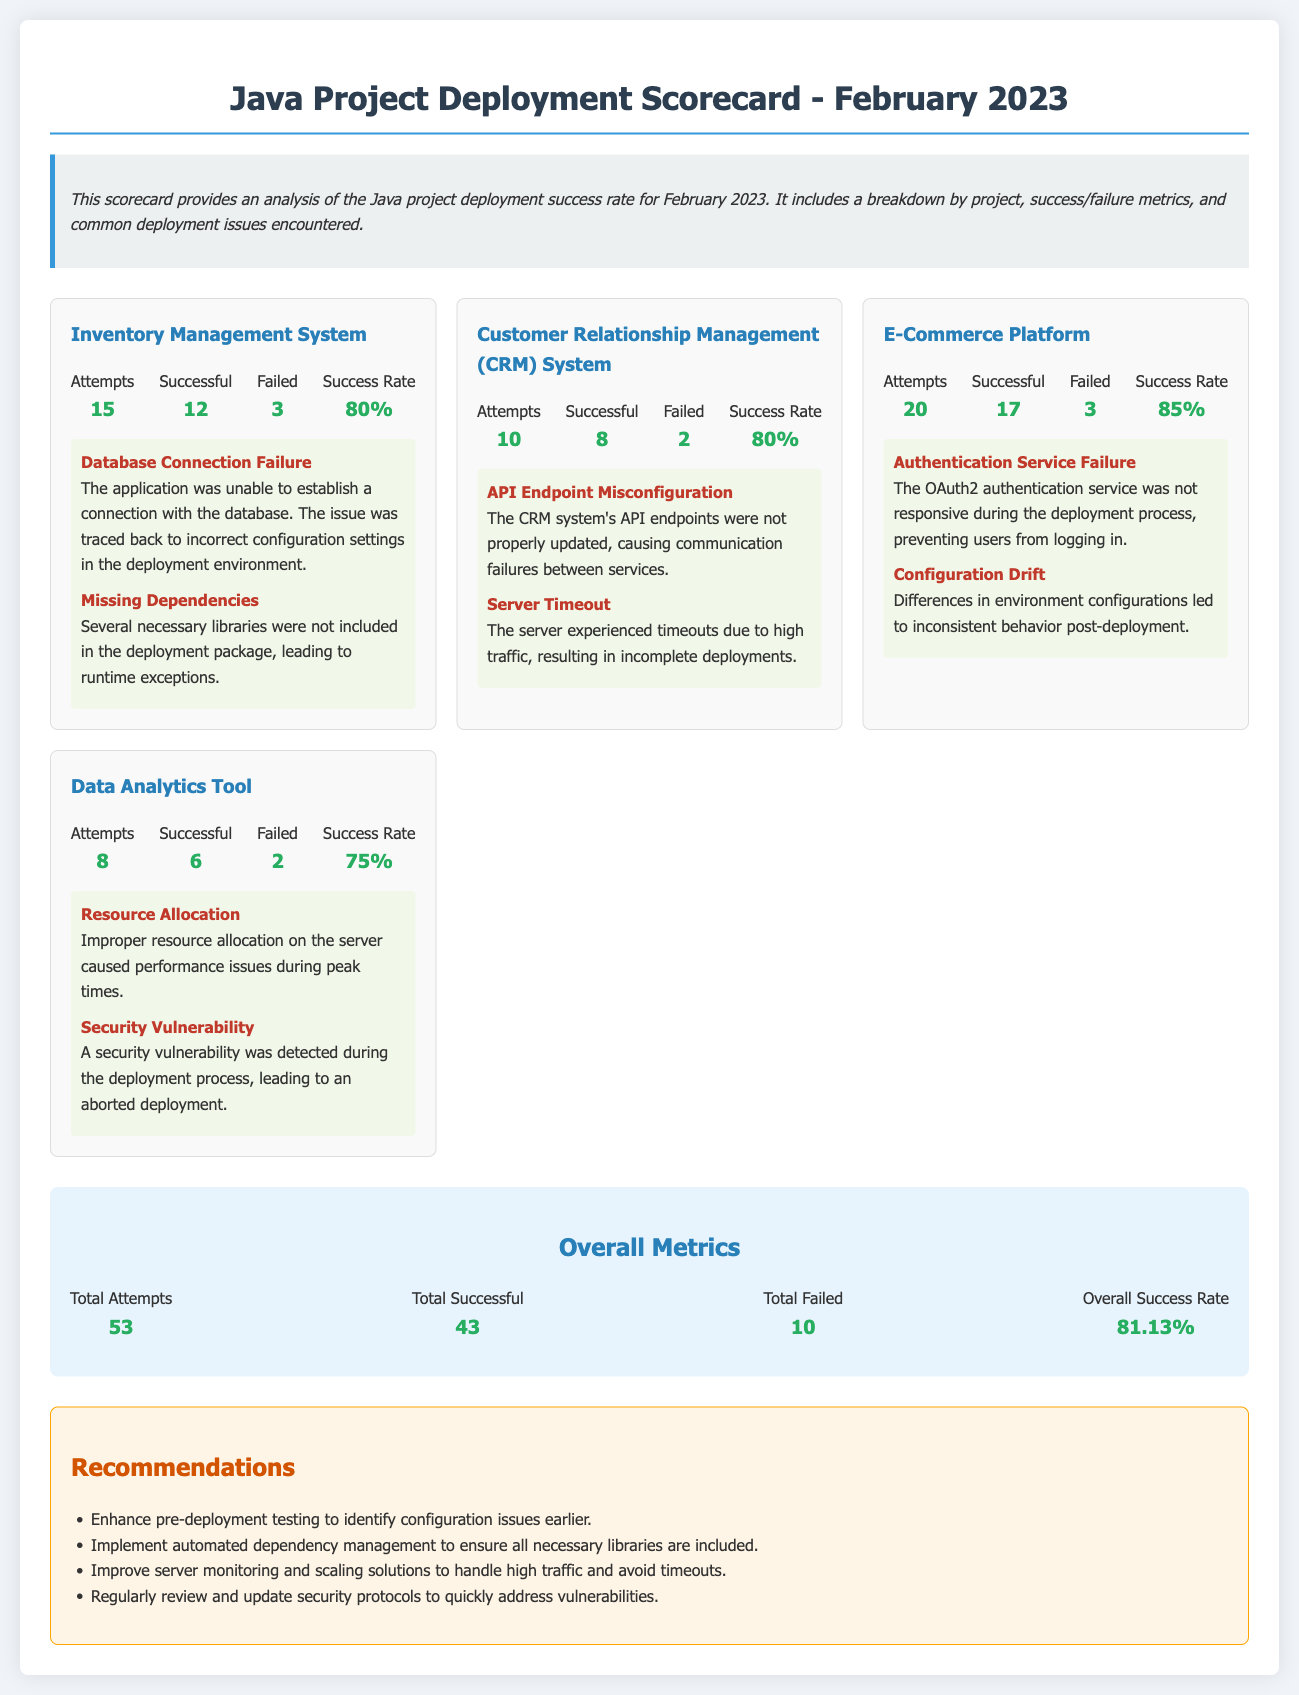What is the success rate of the Inventory Management System? The success rate for the Inventory Management System is provided under its metrics section.
Answer: 80% How many total attempts were made across all projects? The total attempts are shown in the overall metrics section by summing the attempts from each project.
Answer: 53 Which project had the highest success rate? By comparing the success rates of each project listed, the one with the highest rate can be determined.
Answer: E-Commerce Platform What was the total number of failures recorded in February 2023? The total failures can be identified by adding the failed metrics of each project in the overall metrics section.
Answer: 10 What issue was identified in the Customer Relationship Management System? The document lists specific deployment issues for each project, mentioning problems for the CRM system.
Answer: API Endpoint Misconfiguration How many successful deployments were recorded for the E-Commerce Platform? This number can be found in the metrics section specific to the E-Commerce Platform.
Answer: 17 What is the overall success rate for all projects combined? The overall success rate is summarized in the overall metrics section by calculating successful attempts over total attempts.
Answer: 81.13% What recommendation is made to address high traffic issues? The recommendations section provides insights into improvements to mitigate high traffic problems.
Answer: Improve server monitoring and scaling solutions Which project had the least number of attempts? By reviewing the attempts for each project, the one with the least can be identified.
Answer: Data Analytics Tool 